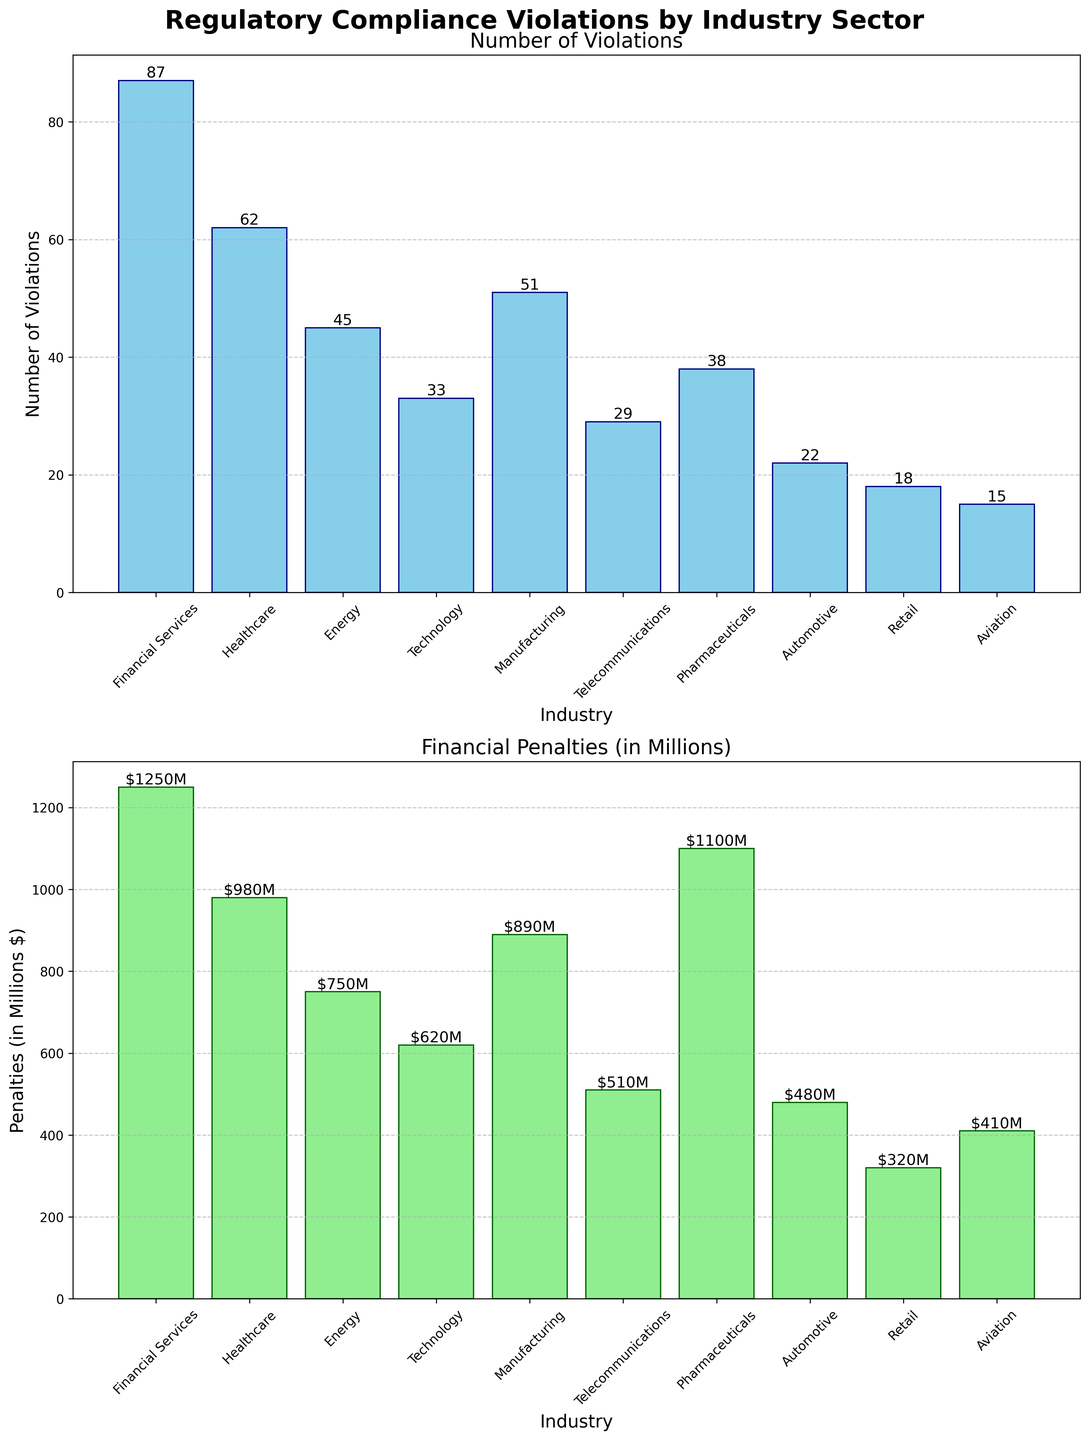What's the title of the figure? The title is displayed at the top of the figure using bold text. Observing the figure, the title is clear and descriptive.
Answer: Regulatory Compliance Violations by Industry Sector Which industry has the highest number of violations? By examining the length of the bars in the top subplot, we identify the industry with the highest bar, indicating the greatest number of violations.
Answer: Financial Services How do the number of violations in Technology compare to those in Manufacturing? We compare the bar heights for Technology and Manufacturing in the top subplot, noting that Manufacturing's bar is higher. This indicates Manufacturing has more violations than Technology.
Answer: Manufacturing has more violations than Technology What is the total financial penalty for the Healthcare, Energy, and Telecommunications industries combined? Sum the heights of the bars representing financial penalties for Healthcare, Energy, and Telecommunications from the bottom subplot. The values are 980, 750, and 510 million dollars respectively, total = 980 + 750 + 510 = 2240.
Answer: $2240M Which industry has the lowest financial penalties, and what is the value? By identifying the shortest bar in the financial penalties subplot at the bottom, we find the industry with the lowest penalties.
Answer: Retail, $320M What is the difference in financial penalties between the Pharmaceuticals and Automotive industries? Subtract the penalty value for the Automotive industry from the penalty value for Pharmaceuticals, using values from the bottom subplot. Pharmaceuticals have penalties of 1100 million dollars, and Automotive has 480 million dollars. The difference is 1100 - 480 = 620.
Answer: $620M How many industries have more than 50 violations? Count the number of bars in the top subplot exceeding the height that equates to 50. Financial Services, Healthcare, Manufacturing, and Energy each have more than 50 violations.
Answer: 4 Of the two subplots, which one uses color light green? By inspecting the colors used in the bars of both subplots, we see that the light green color is used in the bottom subplot representing financial penalties.
Answer: Financial Penalties Are there any industries where financial penalties exceed the number of violations? Compare the values of violations (top subplot) with the financial penalties (bottom subplot) for each industry. Observing Pharmaceuticals, Financial Services, and Healthcare, we see they indeed have more financial penalties than violations.
Answer: Yes What is the combined number of violations in the Healthcare and Financial Services industries? Sum the number of violations presented for Healthcare and Financial Services using the values from the top subplot: 62 + 87 = 149.
Answer: 149 